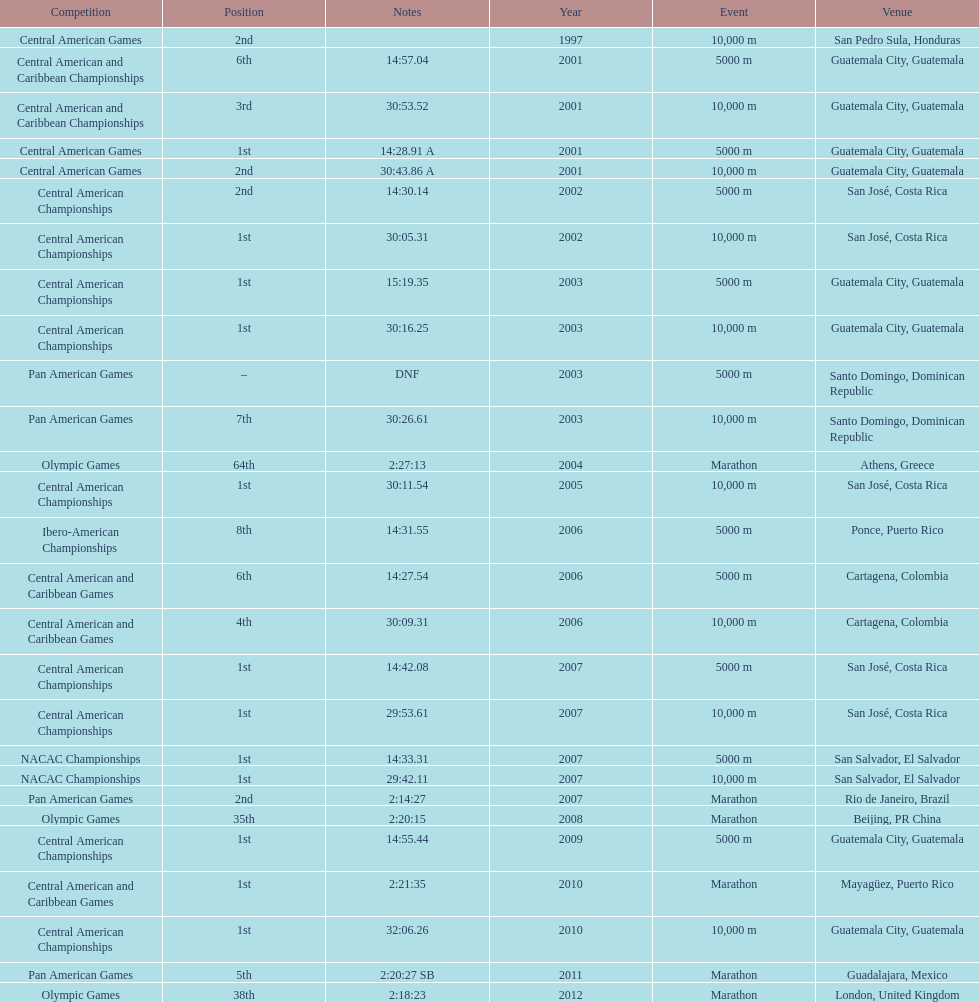Would you mind parsing the complete table? {'header': ['Competition', 'Position', 'Notes', 'Year', 'Event', 'Venue'], 'rows': [['Central American Games', '2nd', '', '1997', '10,000 m', 'San Pedro Sula, Honduras'], ['Central American and Caribbean Championships', '6th', '14:57.04', '2001', '5000 m', 'Guatemala City, Guatemala'], ['Central American and Caribbean Championships', '3rd', '30:53.52', '2001', '10,000 m', 'Guatemala City, Guatemala'], ['Central American Games', '1st', '14:28.91 A', '2001', '5000 m', 'Guatemala City, Guatemala'], ['Central American Games', '2nd', '30:43.86 A', '2001', '10,000 m', 'Guatemala City, Guatemala'], ['Central American Championships', '2nd', '14:30.14', '2002', '5000 m', 'San José, Costa Rica'], ['Central American Championships', '1st', '30:05.31', '2002', '10,000 m', 'San José, Costa Rica'], ['Central American Championships', '1st', '15:19.35', '2003', '5000 m', 'Guatemala City, Guatemala'], ['Central American Championships', '1st', '30:16.25', '2003', '10,000 m', 'Guatemala City, Guatemala'], ['Pan American Games', '–', 'DNF', '2003', '5000 m', 'Santo Domingo, Dominican Republic'], ['Pan American Games', '7th', '30:26.61', '2003', '10,000 m', 'Santo Domingo, Dominican Republic'], ['Olympic Games', '64th', '2:27:13', '2004', 'Marathon', 'Athens, Greece'], ['Central American Championships', '1st', '30:11.54', '2005', '10,000 m', 'San José, Costa Rica'], ['Ibero-American Championships', '8th', '14:31.55', '2006', '5000 m', 'Ponce, Puerto Rico'], ['Central American and Caribbean Games', '6th', '14:27.54', '2006', '5000 m', 'Cartagena, Colombia'], ['Central American and Caribbean Games', '4th', '30:09.31', '2006', '10,000 m', 'Cartagena, Colombia'], ['Central American Championships', '1st', '14:42.08', '2007', '5000 m', 'San José, Costa Rica'], ['Central American Championships', '1st', '29:53.61', '2007', '10,000 m', 'San José, Costa Rica'], ['NACAC Championships', '1st', '14:33.31', '2007', '5000 m', 'San Salvador, El Salvador'], ['NACAC Championships', '1st', '29:42.11', '2007', '10,000 m', 'San Salvador, El Salvador'], ['Pan American Games', '2nd', '2:14:27', '2007', 'Marathon', 'Rio de Janeiro, Brazil'], ['Olympic Games', '35th', '2:20:15', '2008', 'Marathon', 'Beijing, PR China'], ['Central American Championships', '1st', '14:55.44', '2009', '5000 m', 'Guatemala City, Guatemala'], ['Central American and Caribbean Games', '1st', '2:21:35', '2010', 'Marathon', 'Mayagüez, Puerto Rico'], ['Central American Championships', '1st', '32:06.26', '2010', '10,000 m', 'Guatemala City, Guatemala'], ['Pan American Games', '5th', '2:20:27 SB', '2011', 'Marathon', 'Guadalajara, Mexico'], ['Olympic Games', '38th', '2:18:23', '2012', 'Marathon', 'London, United Kingdom']]} Which of each game in 2007 was in the 2nd position? Pan American Games. 